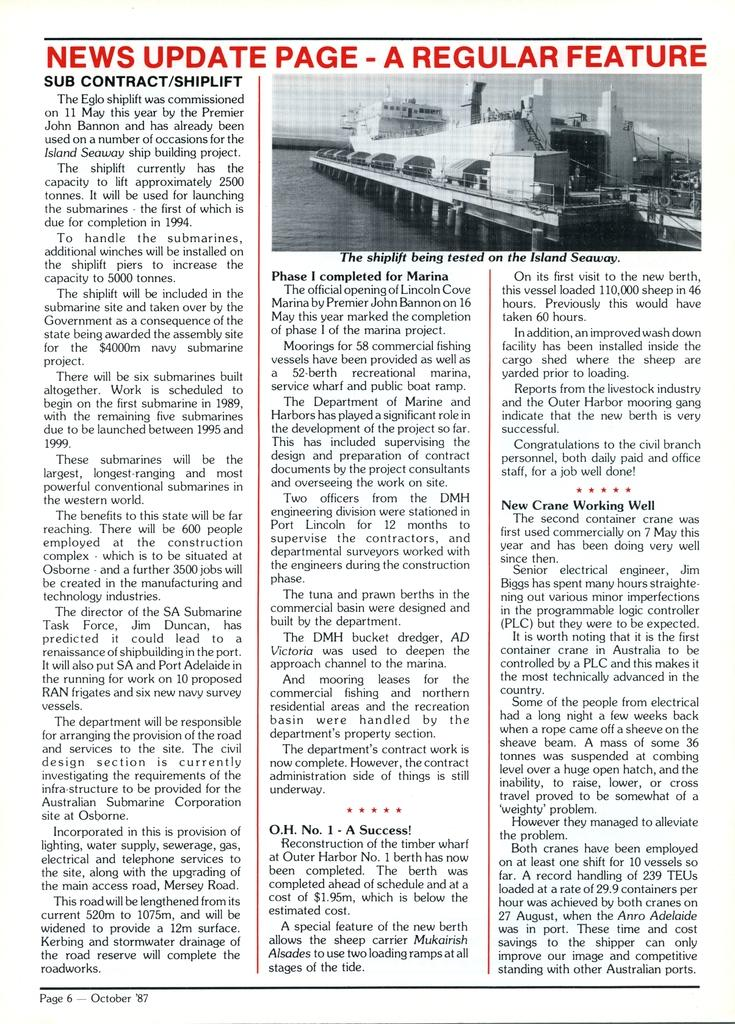<image>
Describe the image concisely. A page of print that says News Update Page at the top of it. 